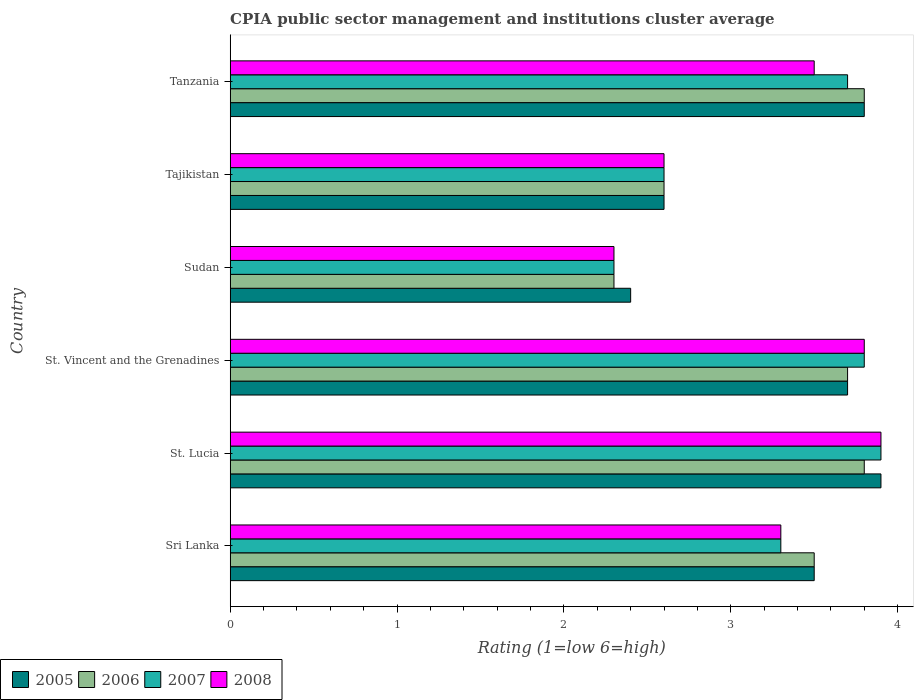How many groups of bars are there?
Keep it short and to the point. 6. Are the number of bars per tick equal to the number of legend labels?
Offer a terse response. Yes. How many bars are there on the 2nd tick from the bottom?
Ensure brevity in your answer.  4. What is the label of the 6th group of bars from the top?
Offer a terse response. Sri Lanka. What is the CPIA rating in 2008 in St. Vincent and the Grenadines?
Make the answer very short. 3.8. Across all countries, what is the maximum CPIA rating in 2008?
Your answer should be very brief. 3.9. Across all countries, what is the minimum CPIA rating in 2008?
Keep it short and to the point. 2.3. In which country was the CPIA rating in 2008 maximum?
Offer a very short reply. St. Lucia. In which country was the CPIA rating in 2006 minimum?
Keep it short and to the point. Sudan. What is the total CPIA rating in 2007 in the graph?
Ensure brevity in your answer.  19.6. What is the difference between the CPIA rating in 2007 in Sri Lanka and that in Tanzania?
Provide a short and direct response. -0.4. What is the average CPIA rating in 2008 per country?
Provide a short and direct response. 3.23. What is the ratio of the CPIA rating in 2006 in St. Vincent and the Grenadines to that in Sudan?
Offer a terse response. 1.61. Is the CPIA rating in 2007 in Tajikistan less than that in Tanzania?
Offer a very short reply. Yes. What is the difference between the highest and the second highest CPIA rating in 2008?
Your answer should be compact. 0.1. What is the difference between the highest and the lowest CPIA rating in 2006?
Your response must be concise. 1.5. In how many countries, is the CPIA rating in 2007 greater than the average CPIA rating in 2007 taken over all countries?
Make the answer very short. 4. Is the sum of the CPIA rating in 2008 in St. Vincent and the Grenadines and Tajikistan greater than the maximum CPIA rating in 2005 across all countries?
Your response must be concise. Yes. Is it the case that in every country, the sum of the CPIA rating in 2008 and CPIA rating in 2007 is greater than the sum of CPIA rating in 2006 and CPIA rating in 2005?
Keep it short and to the point. No. What does the 3rd bar from the top in Tajikistan represents?
Your answer should be very brief. 2006. Is it the case that in every country, the sum of the CPIA rating in 2006 and CPIA rating in 2008 is greater than the CPIA rating in 2005?
Keep it short and to the point. Yes. Does the graph contain any zero values?
Give a very brief answer. No. Does the graph contain grids?
Your answer should be very brief. No. How many legend labels are there?
Make the answer very short. 4. How are the legend labels stacked?
Offer a terse response. Horizontal. What is the title of the graph?
Give a very brief answer. CPIA public sector management and institutions cluster average. What is the label or title of the Y-axis?
Ensure brevity in your answer.  Country. What is the Rating (1=low 6=high) of 2005 in Sri Lanka?
Your answer should be compact. 3.5. What is the Rating (1=low 6=high) in 2006 in St. Lucia?
Provide a short and direct response. 3.8. What is the Rating (1=low 6=high) of 2005 in St. Vincent and the Grenadines?
Provide a short and direct response. 3.7. What is the Rating (1=low 6=high) in 2006 in St. Vincent and the Grenadines?
Your response must be concise. 3.7. What is the Rating (1=low 6=high) in 2008 in St. Vincent and the Grenadines?
Your answer should be very brief. 3.8. What is the Rating (1=low 6=high) in 2005 in Sudan?
Give a very brief answer. 2.4. What is the Rating (1=low 6=high) of 2008 in Tajikistan?
Offer a terse response. 2.6. What is the Rating (1=low 6=high) in 2005 in Tanzania?
Provide a short and direct response. 3.8. What is the Rating (1=low 6=high) of 2008 in Tanzania?
Keep it short and to the point. 3.5. Across all countries, what is the maximum Rating (1=low 6=high) of 2006?
Give a very brief answer. 3.8. Across all countries, what is the minimum Rating (1=low 6=high) of 2005?
Make the answer very short. 2.4. What is the total Rating (1=low 6=high) in 2007 in the graph?
Make the answer very short. 19.6. What is the total Rating (1=low 6=high) in 2008 in the graph?
Your response must be concise. 19.4. What is the difference between the Rating (1=low 6=high) of 2007 in Sri Lanka and that in St. Lucia?
Keep it short and to the point. -0.6. What is the difference between the Rating (1=low 6=high) of 2008 in Sri Lanka and that in St. Vincent and the Grenadines?
Provide a short and direct response. -0.5. What is the difference between the Rating (1=low 6=high) of 2006 in Sri Lanka and that in Sudan?
Your answer should be compact. 1.2. What is the difference between the Rating (1=low 6=high) in 2008 in Sri Lanka and that in Sudan?
Offer a terse response. 1. What is the difference between the Rating (1=low 6=high) of 2005 in Sri Lanka and that in Tajikistan?
Provide a short and direct response. 0.9. What is the difference between the Rating (1=low 6=high) of 2007 in Sri Lanka and that in Tajikistan?
Provide a succinct answer. 0.7. What is the difference between the Rating (1=low 6=high) of 2008 in Sri Lanka and that in Tajikistan?
Ensure brevity in your answer.  0.7. What is the difference between the Rating (1=low 6=high) of 2008 in Sri Lanka and that in Tanzania?
Make the answer very short. -0.2. What is the difference between the Rating (1=low 6=high) in 2005 in St. Lucia and that in St. Vincent and the Grenadines?
Your answer should be very brief. 0.2. What is the difference between the Rating (1=low 6=high) of 2008 in St. Lucia and that in St. Vincent and the Grenadines?
Your response must be concise. 0.1. What is the difference between the Rating (1=low 6=high) of 2005 in St. Lucia and that in Sudan?
Your answer should be very brief. 1.5. What is the difference between the Rating (1=low 6=high) in 2007 in St. Lucia and that in Sudan?
Keep it short and to the point. 1.6. What is the difference between the Rating (1=low 6=high) of 2008 in St. Lucia and that in Sudan?
Offer a terse response. 1.6. What is the difference between the Rating (1=low 6=high) in 2005 in St. Lucia and that in Tajikistan?
Your answer should be very brief. 1.3. What is the difference between the Rating (1=low 6=high) of 2007 in St. Lucia and that in Tajikistan?
Keep it short and to the point. 1.3. What is the difference between the Rating (1=low 6=high) of 2008 in St. Lucia and that in Tajikistan?
Give a very brief answer. 1.3. What is the difference between the Rating (1=low 6=high) in 2005 in St. Lucia and that in Tanzania?
Your response must be concise. 0.1. What is the difference between the Rating (1=low 6=high) in 2008 in St. Lucia and that in Tanzania?
Offer a very short reply. 0.4. What is the difference between the Rating (1=low 6=high) of 2008 in St. Vincent and the Grenadines and that in Sudan?
Give a very brief answer. 1.5. What is the difference between the Rating (1=low 6=high) in 2005 in St. Vincent and the Grenadines and that in Tajikistan?
Your answer should be compact. 1.1. What is the difference between the Rating (1=low 6=high) of 2005 in St. Vincent and the Grenadines and that in Tanzania?
Give a very brief answer. -0.1. What is the difference between the Rating (1=low 6=high) of 2006 in St. Vincent and the Grenadines and that in Tanzania?
Your answer should be very brief. -0.1. What is the difference between the Rating (1=low 6=high) in 2007 in St. Vincent and the Grenadines and that in Tanzania?
Your answer should be compact. 0.1. What is the difference between the Rating (1=low 6=high) of 2007 in Sudan and that in Tajikistan?
Your answer should be compact. -0.3. What is the difference between the Rating (1=low 6=high) in 2005 in Tajikistan and that in Tanzania?
Make the answer very short. -1.2. What is the difference between the Rating (1=low 6=high) in 2007 in Tajikistan and that in Tanzania?
Ensure brevity in your answer.  -1.1. What is the difference between the Rating (1=low 6=high) of 2008 in Tajikistan and that in Tanzania?
Ensure brevity in your answer.  -0.9. What is the difference between the Rating (1=low 6=high) in 2006 in Sri Lanka and the Rating (1=low 6=high) in 2007 in St. Lucia?
Offer a very short reply. -0.4. What is the difference between the Rating (1=low 6=high) of 2005 in Sri Lanka and the Rating (1=low 6=high) of 2007 in St. Vincent and the Grenadines?
Your answer should be compact. -0.3. What is the difference between the Rating (1=low 6=high) of 2005 in Sri Lanka and the Rating (1=low 6=high) of 2008 in St. Vincent and the Grenadines?
Give a very brief answer. -0.3. What is the difference between the Rating (1=low 6=high) of 2006 in Sri Lanka and the Rating (1=low 6=high) of 2007 in St. Vincent and the Grenadines?
Your answer should be compact. -0.3. What is the difference between the Rating (1=low 6=high) in 2006 in Sri Lanka and the Rating (1=low 6=high) in 2008 in St. Vincent and the Grenadines?
Give a very brief answer. -0.3. What is the difference between the Rating (1=low 6=high) in 2007 in Sri Lanka and the Rating (1=low 6=high) in 2008 in St. Vincent and the Grenadines?
Your answer should be compact. -0.5. What is the difference between the Rating (1=low 6=high) of 2005 in Sri Lanka and the Rating (1=low 6=high) of 2008 in Sudan?
Your answer should be very brief. 1.2. What is the difference between the Rating (1=low 6=high) in 2006 in Sri Lanka and the Rating (1=low 6=high) in 2008 in Sudan?
Provide a succinct answer. 1.2. What is the difference between the Rating (1=low 6=high) of 2007 in Sri Lanka and the Rating (1=low 6=high) of 2008 in Sudan?
Ensure brevity in your answer.  1. What is the difference between the Rating (1=low 6=high) of 2005 in Sri Lanka and the Rating (1=low 6=high) of 2007 in Tajikistan?
Ensure brevity in your answer.  0.9. What is the difference between the Rating (1=low 6=high) in 2005 in Sri Lanka and the Rating (1=low 6=high) in 2008 in Tajikistan?
Your response must be concise. 0.9. What is the difference between the Rating (1=low 6=high) of 2006 in Sri Lanka and the Rating (1=low 6=high) of 2007 in Tajikistan?
Give a very brief answer. 0.9. What is the difference between the Rating (1=low 6=high) of 2007 in Sri Lanka and the Rating (1=low 6=high) of 2008 in Tajikistan?
Offer a terse response. 0.7. What is the difference between the Rating (1=low 6=high) in 2005 in Sri Lanka and the Rating (1=low 6=high) in 2008 in Tanzania?
Your answer should be compact. 0. What is the difference between the Rating (1=low 6=high) in 2006 in Sri Lanka and the Rating (1=low 6=high) in 2008 in Tanzania?
Offer a terse response. 0. What is the difference between the Rating (1=low 6=high) in 2007 in Sri Lanka and the Rating (1=low 6=high) in 2008 in Tanzania?
Provide a short and direct response. -0.2. What is the difference between the Rating (1=low 6=high) of 2005 in St. Lucia and the Rating (1=low 6=high) of 2006 in St. Vincent and the Grenadines?
Your answer should be very brief. 0.2. What is the difference between the Rating (1=low 6=high) in 2006 in St. Lucia and the Rating (1=low 6=high) in 2007 in St. Vincent and the Grenadines?
Give a very brief answer. 0. What is the difference between the Rating (1=low 6=high) in 2005 in St. Lucia and the Rating (1=low 6=high) in 2006 in Sudan?
Make the answer very short. 1.6. What is the difference between the Rating (1=low 6=high) in 2006 in St. Lucia and the Rating (1=low 6=high) in 2007 in Sudan?
Your answer should be compact. 1.5. What is the difference between the Rating (1=low 6=high) in 2006 in St. Lucia and the Rating (1=low 6=high) in 2008 in Sudan?
Your response must be concise. 1.5. What is the difference between the Rating (1=low 6=high) of 2007 in St. Lucia and the Rating (1=low 6=high) of 2008 in Sudan?
Provide a short and direct response. 1.6. What is the difference between the Rating (1=low 6=high) in 2005 in St. Lucia and the Rating (1=low 6=high) in 2006 in Tajikistan?
Keep it short and to the point. 1.3. What is the difference between the Rating (1=low 6=high) of 2005 in St. Lucia and the Rating (1=low 6=high) of 2008 in Tajikistan?
Provide a short and direct response. 1.3. What is the difference between the Rating (1=low 6=high) in 2006 in St. Lucia and the Rating (1=low 6=high) in 2007 in Tajikistan?
Your response must be concise. 1.2. What is the difference between the Rating (1=low 6=high) of 2006 in St. Lucia and the Rating (1=low 6=high) of 2008 in Tajikistan?
Provide a short and direct response. 1.2. What is the difference between the Rating (1=low 6=high) in 2005 in St. Lucia and the Rating (1=low 6=high) in 2006 in Tanzania?
Ensure brevity in your answer.  0.1. What is the difference between the Rating (1=low 6=high) in 2005 in St. Lucia and the Rating (1=low 6=high) in 2008 in Tanzania?
Your answer should be very brief. 0.4. What is the difference between the Rating (1=low 6=high) in 2006 in St. Lucia and the Rating (1=low 6=high) in 2007 in Tanzania?
Your answer should be very brief. 0.1. What is the difference between the Rating (1=low 6=high) of 2006 in St. Lucia and the Rating (1=low 6=high) of 2008 in Tanzania?
Keep it short and to the point. 0.3. What is the difference between the Rating (1=low 6=high) of 2007 in St. Lucia and the Rating (1=low 6=high) of 2008 in Tanzania?
Offer a very short reply. 0.4. What is the difference between the Rating (1=low 6=high) in 2005 in St. Vincent and the Grenadines and the Rating (1=low 6=high) in 2006 in Sudan?
Keep it short and to the point. 1.4. What is the difference between the Rating (1=low 6=high) in 2005 in St. Vincent and the Grenadines and the Rating (1=low 6=high) in 2007 in Sudan?
Keep it short and to the point. 1.4. What is the difference between the Rating (1=low 6=high) of 2005 in St. Vincent and the Grenadines and the Rating (1=low 6=high) of 2008 in Sudan?
Your response must be concise. 1.4. What is the difference between the Rating (1=low 6=high) in 2006 in St. Vincent and the Grenadines and the Rating (1=low 6=high) in 2008 in Sudan?
Ensure brevity in your answer.  1.4. What is the difference between the Rating (1=low 6=high) of 2006 in St. Vincent and the Grenadines and the Rating (1=low 6=high) of 2008 in Tajikistan?
Make the answer very short. 1.1. What is the difference between the Rating (1=low 6=high) in 2005 in St. Vincent and the Grenadines and the Rating (1=low 6=high) in 2006 in Tanzania?
Provide a succinct answer. -0.1. What is the difference between the Rating (1=low 6=high) of 2006 in St. Vincent and the Grenadines and the Rating (1=low 6=high) of 2008 in Tanzania?
Your response must be concise. 0.2. What is the difference between the Rating (1=low 6=high) of 2007 in St. Vincent and the Grenadines and the Rating (1=low 6=high) of 2008 in Tanzania?
Provide a short and direct response. 0.3. What is the difference between the Rating (1=low 6=high) in 2005 in Sudan and the Rating (1=low 6=high) in 2007 in Tajikistan?
Your response must be concise. -0.2. What is the difference between the Rating (1=low 6=high) in 2005 in Sudan and the Rating (1=low 6=high) in 2006 in Tanzania?
Your answer should be compact. -1.4. What is the difference between the Rating (1=low 6=high) in 2005 in Sudan and the Rating (1=low 6=high) in 2007 in Tanzania?
Keep it short and to the point. -1.3. What is the difference between the Rating (1=low 6=high) in 2006 in Sudan and the Rating (1=low 6=high) in 2007 in Tanzania?
Provide a short and direct response. -1.4. What is the difference between the Rating (1=low 6=high) of 2006 in Sudan and the Rating (1=low 6=high) of 2008 in Tanzania?
Your answer should be compact. -1.2. What is the difference between the Rating (1=low 6=high) of 2007 in Sudan and the Rating (1=low 6=high) of 2008 in Tanzania?
Keep it short and to the point. -1.2. What is the difference between the Rating (1=low 6=high) in 2005 in Tajikistan and the Rating (1=low 6=high) in 2006 in Tanzania?
Keep it short and to the point. -1.2. What is the difference between the Rating (1=low 6=high) of 2005 in Tajikistan and the Rating (1=low 6=high) of 2008 in Tanzania?
Make the answer very short. -0.9. What is the difference between the Rating (1=low 6=high) of 2007 in Tajikistan and the Rating (1=low 6=high) of 2008 in Tanzania?
Provide a succinct answer. -0.9. What is the average Rating (1=low 6=high) in 2005 per country?
Your answer should be compact. 3.32. What is the average Rating (1=low 6=high) in 2006 per country?
Your answer should be compact. 3.28. What is the average Rating (1=low 6=high) in 2007 per country?
Give a very brief answer. 3.27. What is the average Rating (1=low 6=high) in 2008 per country?
Your response must be concise. 3.23. What is the difference between the Rating (1=low 6=high) in 2005 and Rating (1=low 6=high) in 2006 in Sri Lanka?
Your answer should be very brief. 0. What is the difference between the Rating (1=low 6=high) in 2005 and Rating (1=low 6=high) in 2007 in Sri Lanka?
Your response must be concise. 0.2. What is the difference between the Rating (1=low 6=high) of 2005 and Rating (1=low 6=high) of 2008 in Sri Lanka?
Provide a succinct answer. 0.2. What is the difference between the Rating (1=low 6=high) of 2006 and Rating (1=low 6=high) of 2008 in Sri Lanka?
Your response must be concise. 0.2. What is the difference between the Rating (1=low 6=high) of 2007 and Rating (1=low 6=high) of 2008 in Sri Lanka?
Offer a very short reply. 0. What is the difference between the Rating (1=low 6=high) of 2005 and Rating (1=low 6=high) of 2007 in St. Lucia?
Provide a short and direct response. 0. What is the difference between the Rating (1=low 6=high) of 2006 and Rating (1=low 6=high) of 2007 in St. Lucia?
Offer a very short reply. -0.1. What is the difference between the Rating (1=low 6=high) of 2005 and Rating (1=low 6=high) of 2006 in St. Vincent and the Grenadines?
Provide a short and direct response. 0. What is the difference between the Rating (1=low 6=high) in 2005 and Rating (1=low 6=high) in 2007 in St. Vincent and the Grenadines?
Give a very brief answer. -0.1. What is the difference between the Rating (1=low 6=high) in 2006 and Rating (1=low 6=high) in 2007 in St. Vincent and the Grenadines?
Provide a succinct answer. -0.1. What is the difference between the Rating (1=low 6=high) of 2005 and Rating (1=low 6=high) of 2006 in Sudan?
Offer a very short reply. 0.1. What is the difference between the Rating (1=low 6=high) in 2005 and Rating (1=low 6=high) in 2007 in Sudan?
Provide a succinct answer. 0.1. What is the difference between the Rating (1=low 6=high) of 2006 and Rating (1=low 6=high) of 2008 in Sudan?
Ensure brevity in your answer.  0. What is the difference between the Rating (1=low 6=high) of 2007 and Rating (1=low 6=high) of 2008 in Sudan?
Your answer should be compact. 0. What is the difference between the Rating (1=low 6=high) of 2005 and Rating (1=low 6=high) of 2006 in Tajikistan?
Make the answer very short. 0. What is the difference between the Rating (1=low 6=high) in 2006 and Rating (1=low 6=high) in 2007 in Tajikistan?
Provide a succinct answer. 0. What is the difference between the Rating (1=low 6=high) of 2006 and Rating (1=low 6=high) of 2008 in Tajikistan?
Your answer should be very brief. 0. What is the difference between the Rating (1=low 6=high) in 2005 and Rating (1=low 6=high) in 2007 in Tanzania?
Your answer should be very brief. 0.1. What is the difference between the Rating (1=low 6=high) in 2006 and Rating (1=low 6=high) in 2007 in Tanzania?
Keep it short and to the point. 0.1. What is the difference between the Rating (1=low 6=high) in 2006 and Rating (1=low 6=high) in 2008 in Tanzania?
Your answer should be very brief. 0.3. What is the ratio of the Rating (1=low 6=high) of 2005 in Sri Lanka to that in St. Lucia?
Offer a very short reply. 0.9. What is the ratio of the Rating (1=low 6=high) of 2006 in Sri Lanka to that in St. Lucia?
Keep it short and to the point. 0.92. What is the ratio of the Rating (1=low 6=high) of 2007 in Sri Lanka to that in St. Lucia?
Your response must be concise. 0.85. What is the ratio of the Rating (1=low 6=high) of 2008 in Sri Lanka to that in St. Lucia?
Your response must be concise. 0.85. What is the ratio of the Rating (1=low 6=high) of 2005 in Sri Lanka to that in St. Vincent and the Grenadines?
Make the answer very short. 0.95. What is the ratio of the Rating (1=low 6=high) of 2006 in Sri Lanka to that in St. Vincent and the Grenadines?
Provide a short and direct response. 0.95. What is the ratio of the Rating (1=low 6=high) in 2007 in Sri Lanka to that in St. Vincent and the Grenadines?
Your response must be concise. 0.87. What is the ratio of the Rating (1=low 6=high) of 2008 in Sri Lanka to that in St. Vincent and the Grenadines?
Keep it short and to the point. 0.87. What is the ratio of the Rating (1=low 6=high) of 2005 in Sri Lanka to that in Sudan?
Provide a succinct answer. 1.46. What is the ratio of the Rating (1=low 6=high) of 2006 in Sri Lanka to that in Sudan?
Your response must be concise. 1.52. What is the ratio of the Rating (1=low 6=high) of 2007 in Sri Lanka to that in Sudan?
Ensure brevity in your answer.  1.43. What is the ratio of the Rating (1=low 6=high) of 2008 in Sri Lanka to that in Sudan?
Ensure brevity in your answer.  1.43. What is the ratio of the Rating (1=low 6=high) in 2005 in Sri Lanka to that in Tajikistan?
Make the answer very short. 1.35. What is the ratio of the Rating (1=low 6=high) in 2006 in Sri Lanka to that in Tajikistan?
Your answer should be very brief. 1.35. What is the ratio of the Rating (1=low 6=high) of 2007 in Sri Lanka to that in Tajikistan?
Make the answer very short. 1.27. What is the ratio of the Rating (1=low 6=high) of 2008 in Sri Lanka to that in Tajikistan?
Provide a succinct answer. 1.27. What is the ratio of the Rating (1=low 6=high) in 2005 in Sri Lanka to that in Tanzania?
Your answer should be compact. 0.92. What is the ratio of the Rating (1=low 6=high) in 2006 in Sri Lanka to that in Tanzania?
Keep it short and to the point. 0.92. What is the ratio of the Rating (1=low 6=high) of 2007 in Sri Lanka to that in Tanzania?
Ensure brevity in your answer.  0.89. What is the ratio of the Rating (1=low 6=high) in 2008 in Sri Lanka to that in Tanzania?
Make the answer very short. 0.94. What is the ratio of the Rating (1=low 6=high) of 2005 in St. Lucia to that in St. Vincent and the Grenadines?
Offer a very short reply. 1.05. What is the ratio of the Rating (1=low 6=high) in 2007 in St. Lucia to that in St. Vincent and the Grenadines?
Provide a succinct answer. 1.03. What is the ratio of the Rating (1=low 6=high) of 2008 in St. Lucia to that in St. Vincent and the Grenadines?
Your answer should be very brief. 1.03. What is the ratio of the Rating (1=low 6=high) of 2005 in St. Lucia to that in Sudan?
Keep it short and to the point. 1.62. What is the ratio of the Rating (1=low 6=high) in 2006 in St. Lucia to that in Sudan?
Your response must be concise. 1.65. What is the ratio of the Rating (1=low 6=high) of 2007 in St. Lucia to that in Sudan?
Your answer should be compact. 1.7. What is the ratio of the Rating (1=low 6=high) in 2008 in St. Lucia to that in Sudan?
Offer a terse response. 1.7. What is the ratio of the Rating (1=low 6=high) of 2006 in St. Lucia to that in Tajikistan?
Offer a terse response. 1.46. What is the ratio of the Rating (1=low 6=high) of 2007 in St. Lucia to that in Tajikistan?
Offer a terse response. 1.5. What is the ratio of the Rating (1=low 6=high) of 2008 in St. Lucia to that in Tajikistan?
Offer a terse response. 1.5. What is the ratio of the Rating (1=low 6=high) in 2005 in St. Lucia to that in Tanzania?
Give a very brief answer. 1.03. What is the ratio of the Rating (1=low 6=high) in 2007 in St. Lucia to that in Tanzania?
Make the answer very short. 1.05. What is the ratio of the Rating (1=low 6=high) of 2008 in St. Lucia to that in Tanzania?
Your answer should be compact. 1.11. What is the ratio of the Rating (1=low 6=high) of 2005 in St. Vincent and the Grenadines to that in Sudan?
Give a very brief answer. 1.54. What is the ratio of the Rating (1=low 6=high) in 2006 in St. Vincent and the Grenadines to that in Sudan?
Make the answer very short. 1.61. What is the ratio of the Rating (1=low 6=high) of 2007 in St. Vincent and the Grenadines to that in Sudan?
Provide a short and direct response. 1.65. What is the ratio of the Rating (1=low 6=high) of 2008 in St. Vincent and the Grenadines to that in Sudan?
Provide a succinct answer. 1.65. What is the ratio of the Rating (1=low 6=high) in 2005 in St. Vincent and the Grenadines to that in Tajikistan?
Give a very brief answer. 1.42. What is the ratio of the Rating (1=low 6=high) of 2006 in St. Vincent and the Grenadines to that in Tajikistan?
Offer a terse response. 1.42. What is the ratio of the Rating (1=low 6=high) in 2007 in St. Vincent and the Grenadines to that in Tajikistan?
Offer a very short reply. 1.46. What is the ratio of the Rating (1=low 6=high) in 2008 in St. Vincent and the Grenadines to that in Tajikistan?
Your answer should be compact. 1.46. What is the ratio of the Rating (1=low 6=high) of 2005 in St. Vincent and the Grenadines to that in Tanzania?
Offer a terse response. 0.97. What is the ratio of the Rating (1=low 6=high) in 2006 in St. Vincent and the Grenadines to that in Tanzania?
Your answer should be very brief. 0.97. What is the ratio of the Rating (1=low 6=high) of 2008 in St. Vincent and the Grenadines to that in Tanzania?
Provide a succinct answer. 1.09. What is the ratio of the Rating (1=low 6=high) of 2006 in Sudan to that in Tajikistan?
Your answer should be very brief. 0.88. What is the ratio of the Rating (1=low 6=high) of 2007 in Sudan to that in Tajikistan?
Offer a terse response. 0.88. What is the ratio of the Rating (1=low 6=high) of 2008 in Sudan to that in Tajikistan?
Make the answer very short. 0.88. What is the ratio of the Rating (1=low 6=high) in 2005 in Sudan to that in Tanzania?
Offer a terse response. 0.63. What is the ratio of the Rating (1=low 6=high) in 2006 in Sudan to that in Tanzania?
Provide a succinct answer. 0.61. What is the ratio of the Rating (1=low 6=high) of 2007 in Sudan to that in Tanzania?
Your answer should be very brief. 0.62. What is the ratio of the Rating (1=low 6=high) in 2008 in Sudan to that in Tanzania?
Offer a terse response. 0.66. What is the ratio of the Rating (1=low 6=high) in 2005 in Tajikistan to that in Tanzania?
Make the answer very short. 0.68. What is the ratio of the Rating (1=low 6=high) of 2006 in Tajikistan to that in Tanzania?
Offer a terse response. 0.68. What is the ratio of the Rating (1=low 6=high) in 2007 in Tajikistan to that in Tanzania?
Offer a terse response. 0.7. What is the ratio of the Rating (1=low 6=high) of 2008 in Tajikistan to that in Tanzania?
Ensure brevity in your answer.  0.74. 